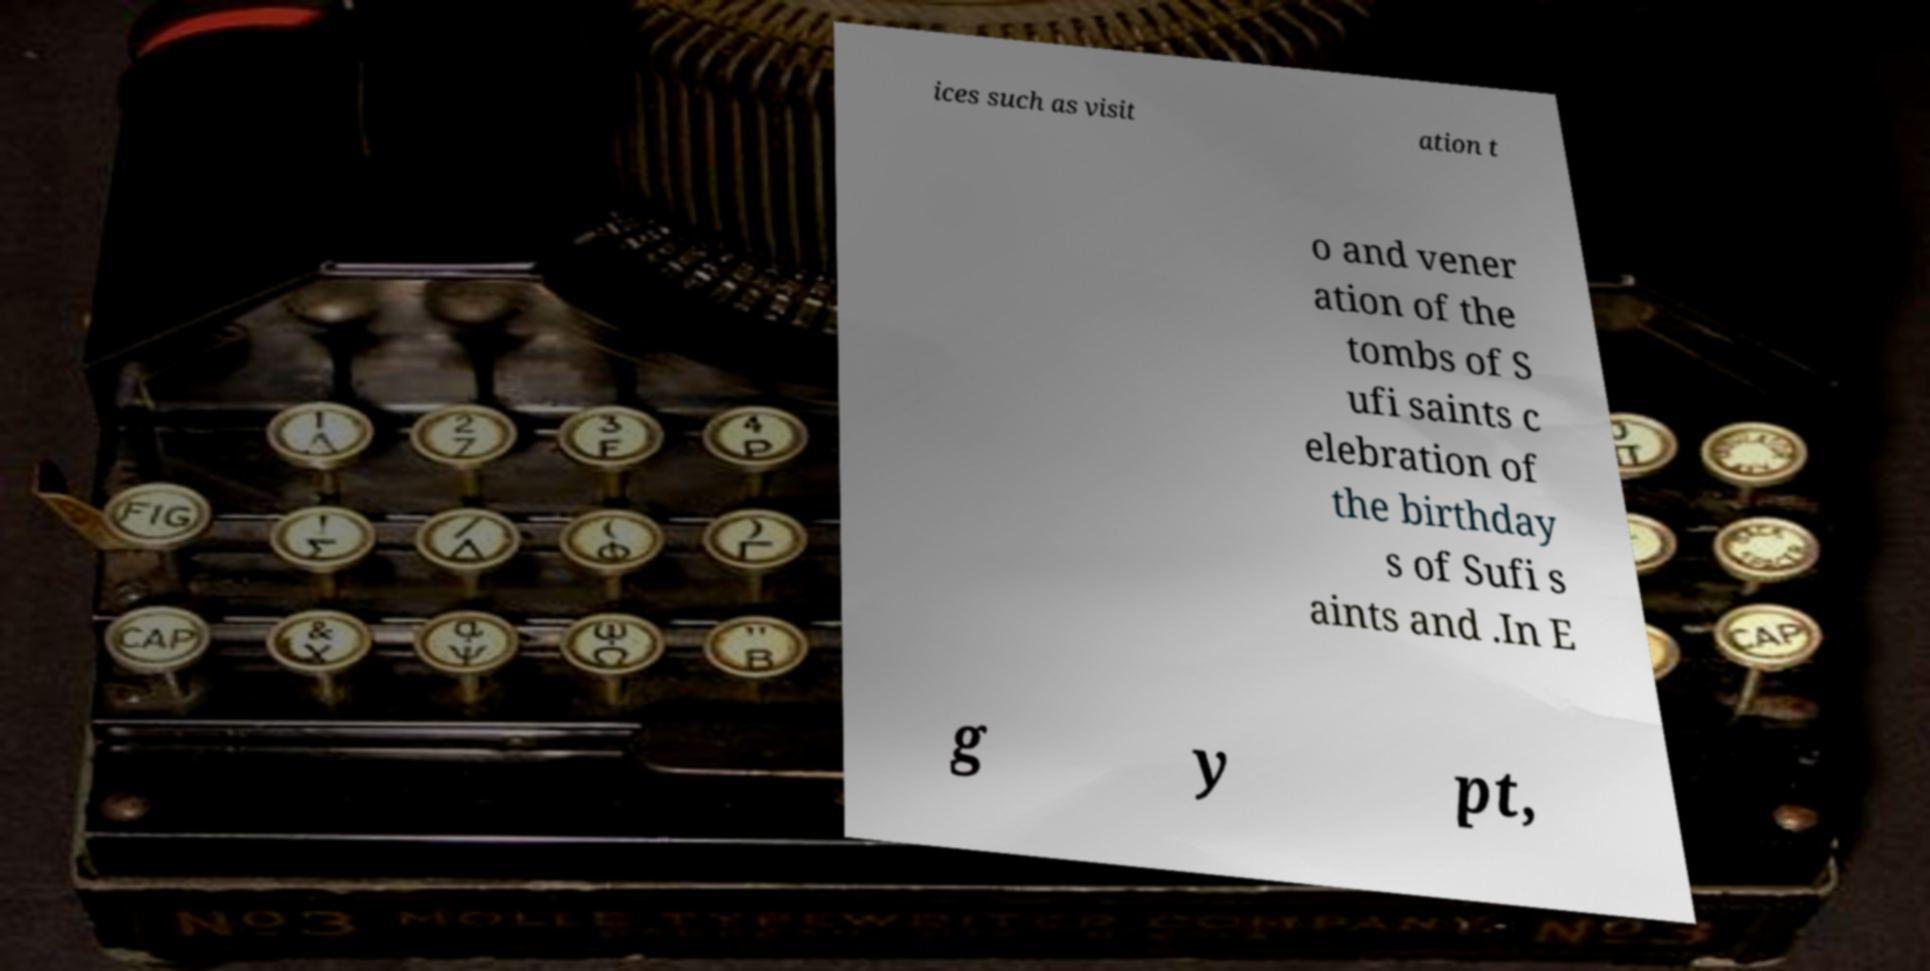Please identify and transcribe the text found in this image. ices such as visit ation t o and vener ation of the tombs of S ufi saints c elebration of the birthday s of Sufi s aints and .In E g y pt, 